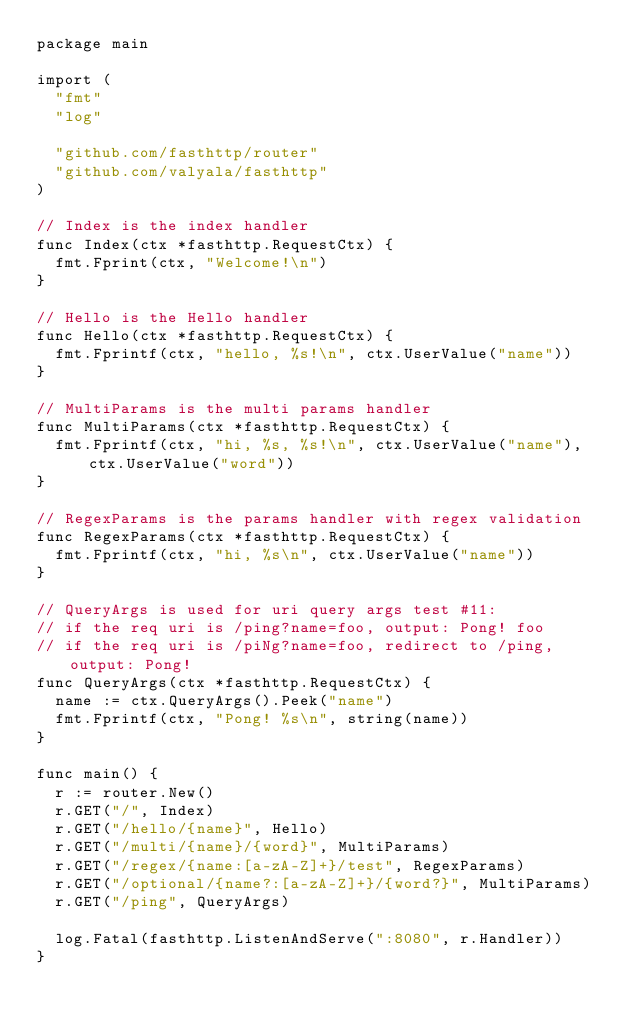<code> <loc_0><loc_0><loc_500><loc_500><_Go_>package main

import (
	"fmt"
	"log"

	"github.com/fasthttp/router"
	"github.com/valyala/fasthttp"
)

// Index is the index handler
func Index(ctx *fasthttp.RequestCtx) {
	fmt.Fprint(ctx, "Welcome!\n")
}

// Hello is the Hello handler
func Hello(ctx *fasthttp.RequestCtx) {
	fmt.Fprintf(ctx, "hello, %s!\n", ctx.UserValue("name"))
}

// MultiParams is the multi params handler
func MultiParams(ctx *fasthttp.RequestCtx) {
	fmt.Fprintf(ctx, "hi, %s, %s!\n", ctx.UserValue("name"), ctx.UserValue("word"))
}

// RegexParams is the params handler with regex validation
func RegexParams(ctx *fasthttp.RequestCtx) {
	fmt.Fprintf(ctx, "hi, %s\n", ctx.UserValue("name"))
}

// QueryArgs is used for uri query args test #11:
// if the req uri is /ping?name=foo, output: Pong! foo
// if the req uri is /piNg?name=foo, redirect to /ping, output: Pong!
func QueryArgs(ctx *fasthttp.RequestCtx) {
	name := ctx.QueryArgs().Peek("name")
	fmt.Fprintf(ctx, "Pong! %s\n", string(name))
}

func main() {
	r := router.New()
	r.GET("/", Index)
	r.GET("/hello/{name}", Hello)
	r.GET("/multi/{name}/{word}", MultiParams)
	r.GET("/regex/{name:[a-zA-Z]+}/test", RegexParams)
	r.GET("/optional/{name?:[a-zA-Z]+}/{word?}", MultiParams)
	r.GET("/ping", QueryArgs)

	log.Fatal(fasthttp.ListenAndServe(":8080", r.Handler))
}
</code> 